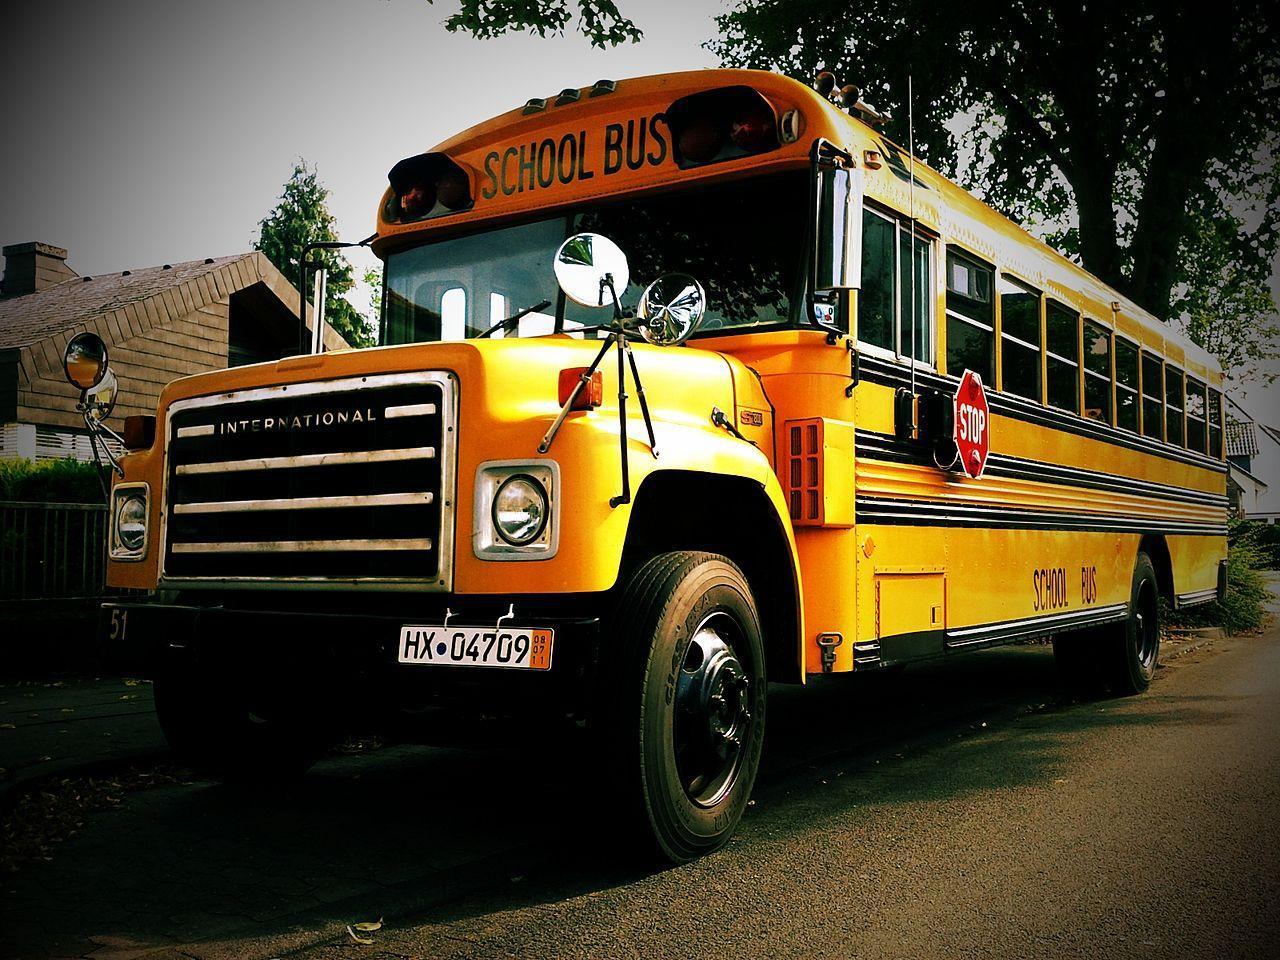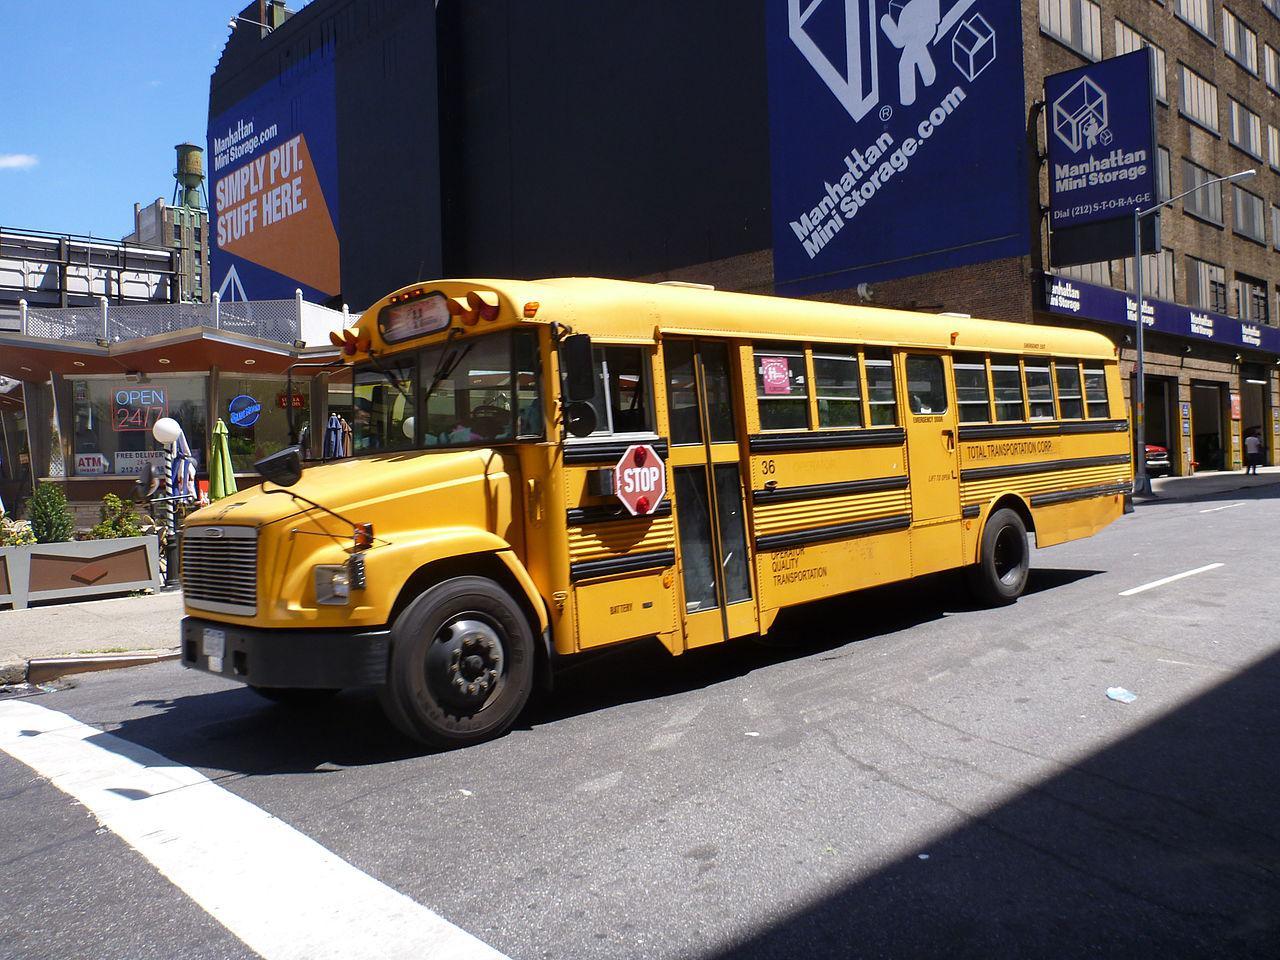The first image is the image on the left, the second image is the image on the right. Evaluate the accuracy of this statement regarding the images: "The left image shows at least one bus heading away from the camera, and the right image shows at least one forward-angled bus.". Is it true? Answer yes or no. No. The first image is the image on the left, the second image is the image on the right. Considering the images on both sides, is "In one of the images you can see the tail lights of a school bus." valid? Answer yes or no. No. 